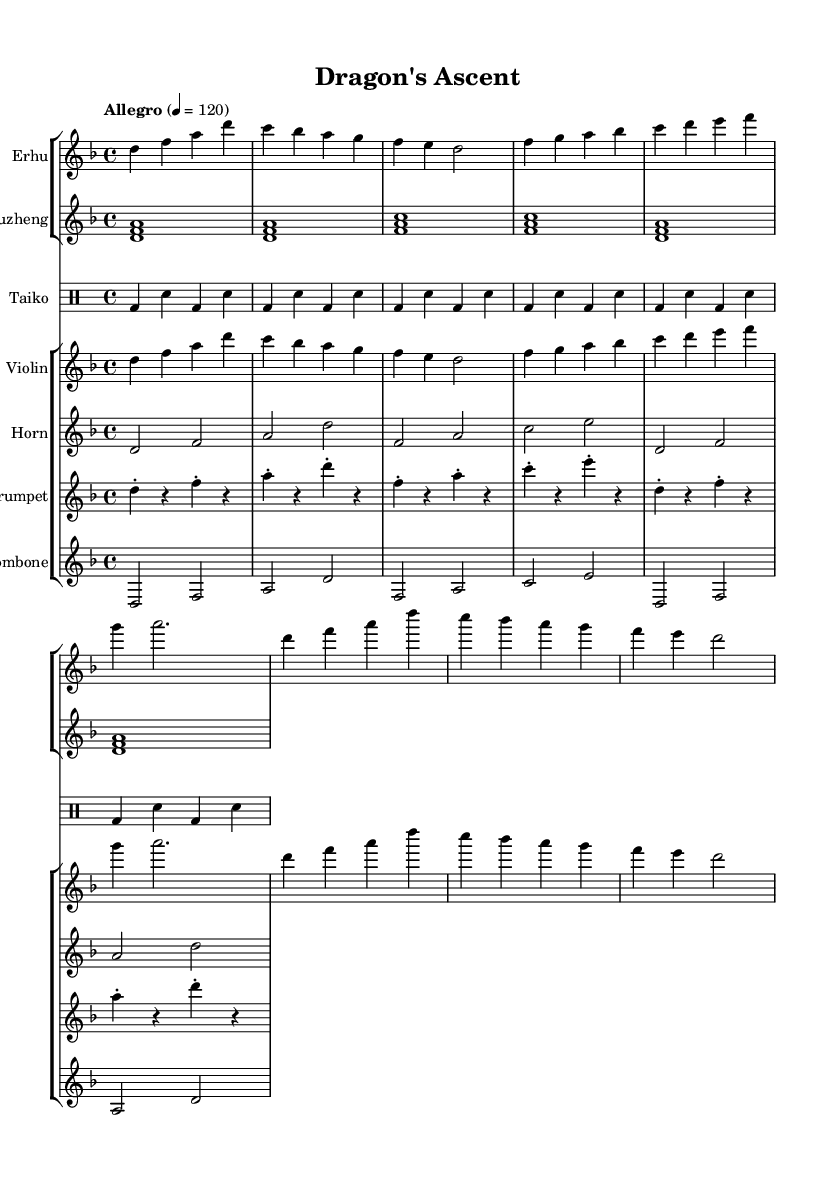What is the key signature of this music? The key signature indicated in the sheet music is D minor, which has one flat (B flat).
Answer: D minor What is the time signature of this piece? The time signature shown in the music is 4/4, which means each measure contains four beats, and each beat is a quarter note.
Answer: 4/4 What is the tempo marking for this symphony? The tempo marking specified in the score is "Allegro," which indicates a fast tempo, roughly around 120 beats per minute.
Answer: Allegro How many distinct instruments are used in this composition? There are five distinct instruments used in the composition: Erhu, Guzheng, Taiko, Violin, and Horn. Counting each unique staff listed confirms this.
Answer: Five Which Eastern instrument is featured prominently in this piece? The instrument most representative of Eastern music in the piece is the Erhu, a traditional Chinese string instrument.
Answer: Erhu What rhythmic pattern is mainly used for the Taiko drums? The rhythmic pattern for the Taiko drums consists primarily of a bass drum and snare alternation, creating a driving percussive effect.
Answer: Bass and snare How does the music blend Eastern and Western elements? The music integrates traditional Eastern instruments like the Erhu and Guzheng with Western orchestral components, such as the Horn and Trombone, demonstrating a fusion of cultural music styles.
Answer: Fusion of styles 